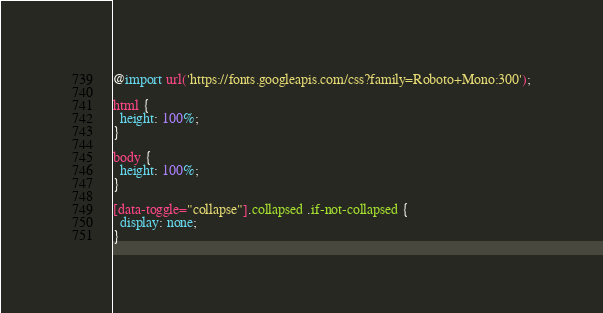<code> <loc_0><loc_0><loc_500><loc_500><_CSS_>@import url('https://fonts.googleapis.com/css?family=Roboto+Mono:300');

html {
  height: 100%;
}

body {
  height: 100%;
}

[data-toggle="collapse"].collapsed .if-not-collapsed {
  display: none;
}
</code> 